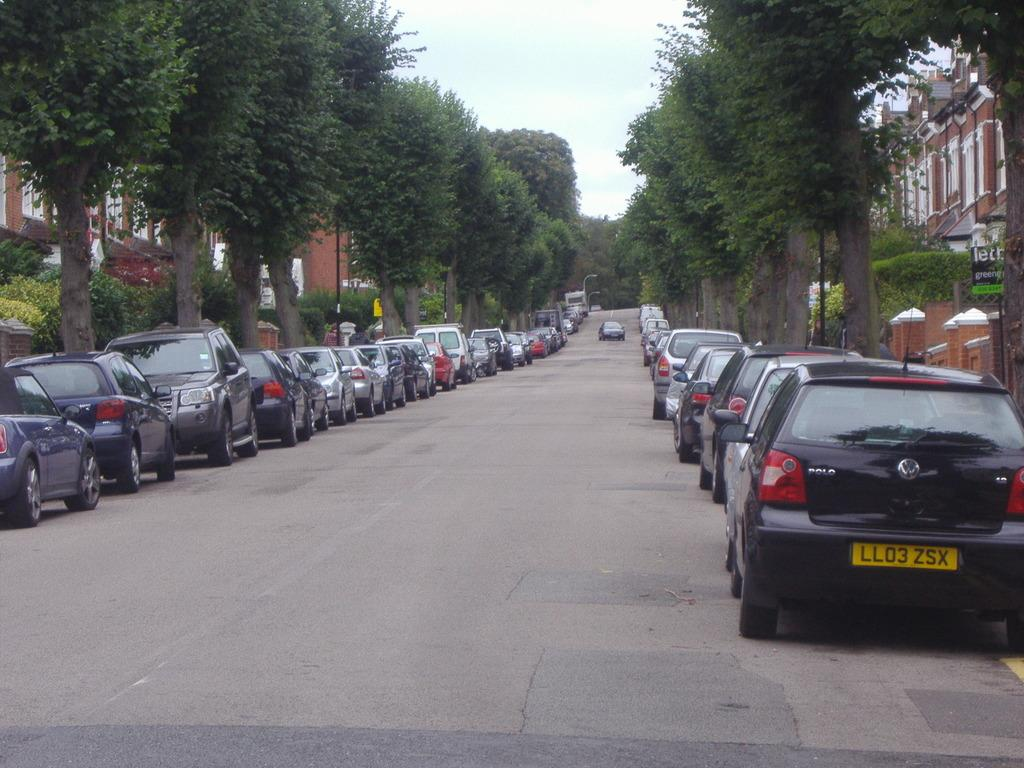What type of vehicles can be seen in the image? There are cars in the image. What natural elements are present in the image? There are trees in the image. What man-made structures are visible in the image? There are buildings in the image. What type of signage is present in the image? There are posters in the image. What type of vertical structures are present in the image? There are poles in the image. What type of pathway is visible in the image? There is a road in the image. What part of the natural environment is visible in the image? The sky is visible in the image. What type of scent can be detected in the image? There is no information about scents in the image, as it only provides visual information. What type of song is being played in the image? There is no information about music or songs in the image, as it only provides visual information. 